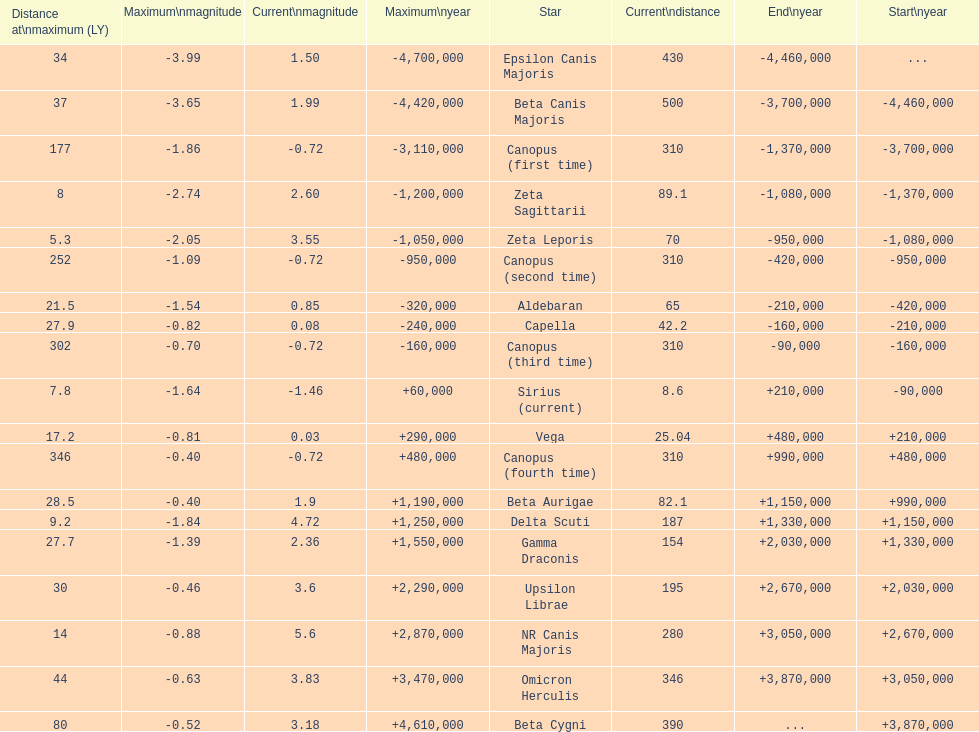How much farther (in ly) is epsilon canis majoris than zeta sagittarii? 26. 